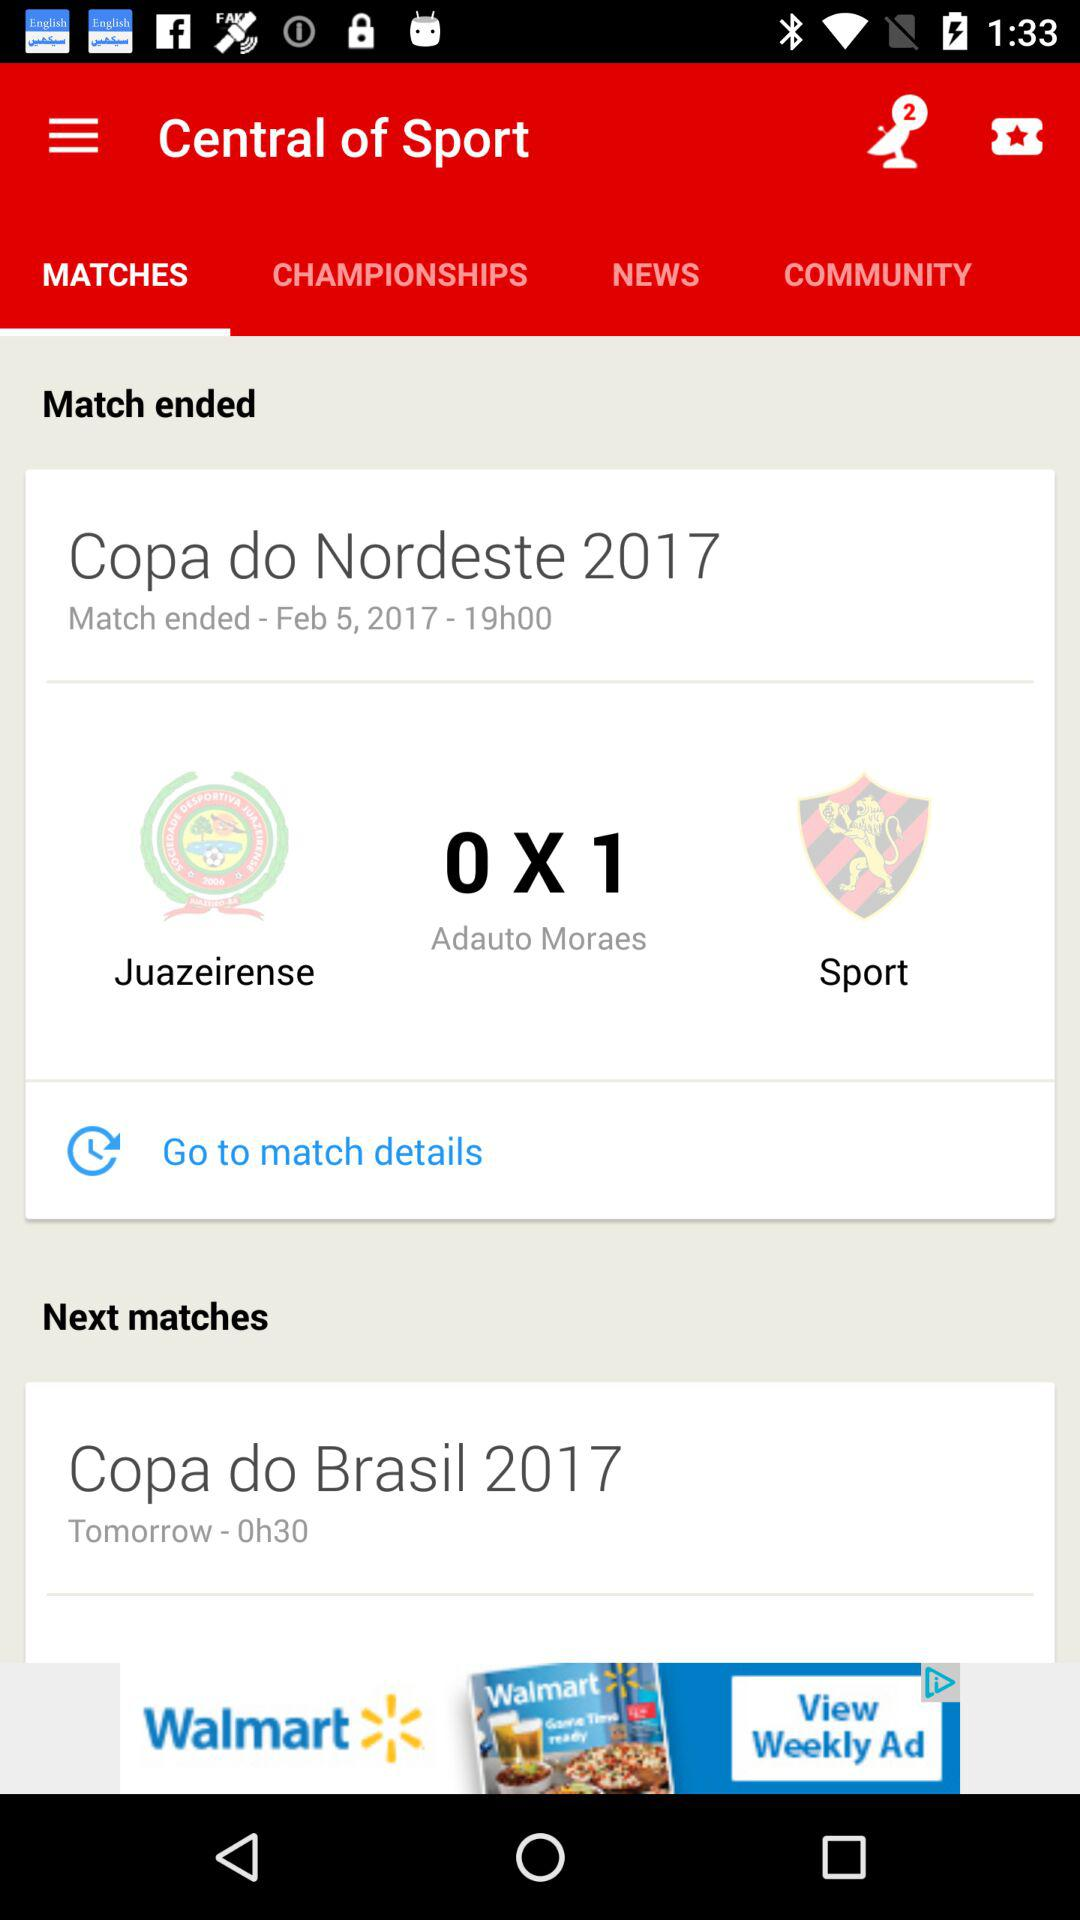What is the name of the team that won the match?
Answer the question using a single word or phrase. Sport 